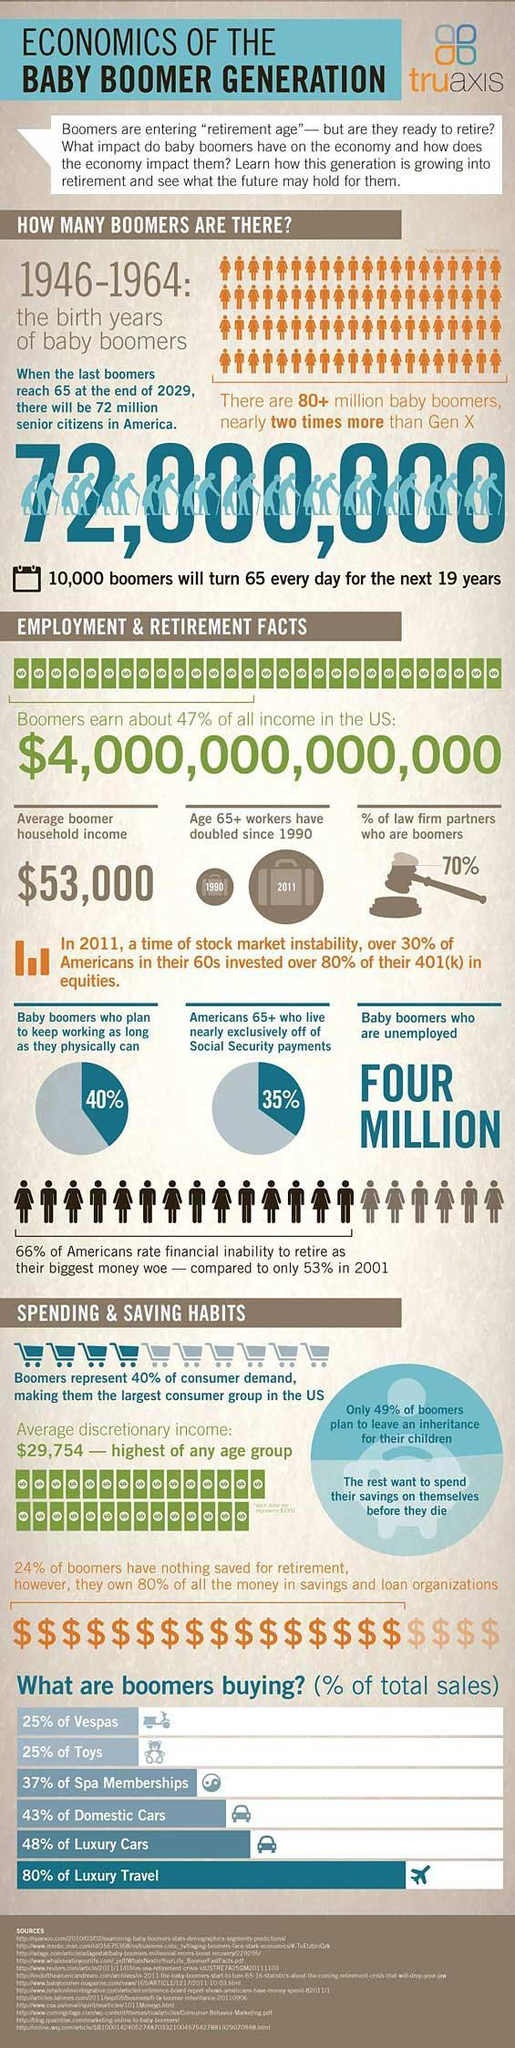What percentage of baby boomers plan to work as long as they are physically strong?
Answer the question with a short phrase. 40% What is the population of baby boomers in America? 72,000,000 What is the average discretionary income of baby boomers in America? $29,754 What is the population of baby boomers who are unemployed in America? FOUR MILLION What is the average boomer household income in America? $53,000 What percentage of baby boomers plan to spend their savings on themselves in America? 51% What percentage of law firm partners are not boomers in America? 30% 